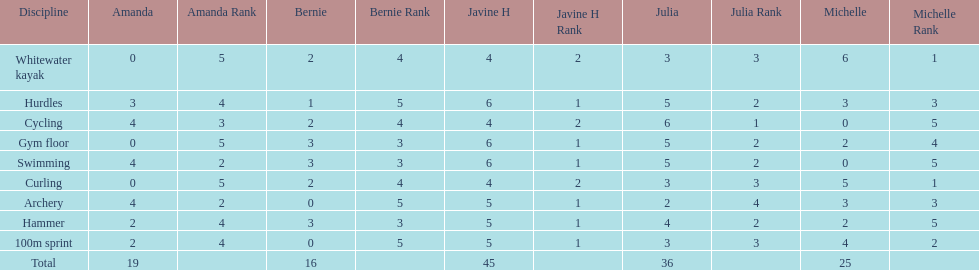What is the first discipline listed on this chart? Whitewater kayak. Parse the table in full. {'header': ['Discipline', 'Amanda', 'Amanda Rank', 'Bernie', 'Bernie Rank', 'Javine H', 'Javine H Rank', 'Julia', 'Julia Rank', 'Michelle', 'Michelle Rank'], 'rows': [['Whitewater kayak', '0', '5', '2', '4', '4', '2', '3', '3', '6', '1'], ['Hurdles', '3', '4', '1', '5', '6', '1', '5', '2', '3', '3'], ['Cycling', '4', '3', '2', '4', '4', '2', '6', '1', '0', '5'], ['Gym floor', '0', '5', '3', '3', '6', '1', '5', '2', '2', '4'], ['Swimming', '4', '2', '3', '3', '6', '1', '5', '2', '0', '5'], ['Curling', '0', '5', '2', '4', '4', '2', '3', '3', '5', '1'], ['Archery', '4', '2', '0', '5', '5', '1', '2', '4', '3', '3'], ['Hammer', '2', '4', '3', '3', '5', '1', '4', '2', '2', '5'], ['100m sprint', '2', '4', '0', '5', '5', '1', '3', '3', '4', '2'], ['Total', '19', '', '16', '', '45', '', '36', '', '25', '']]} 